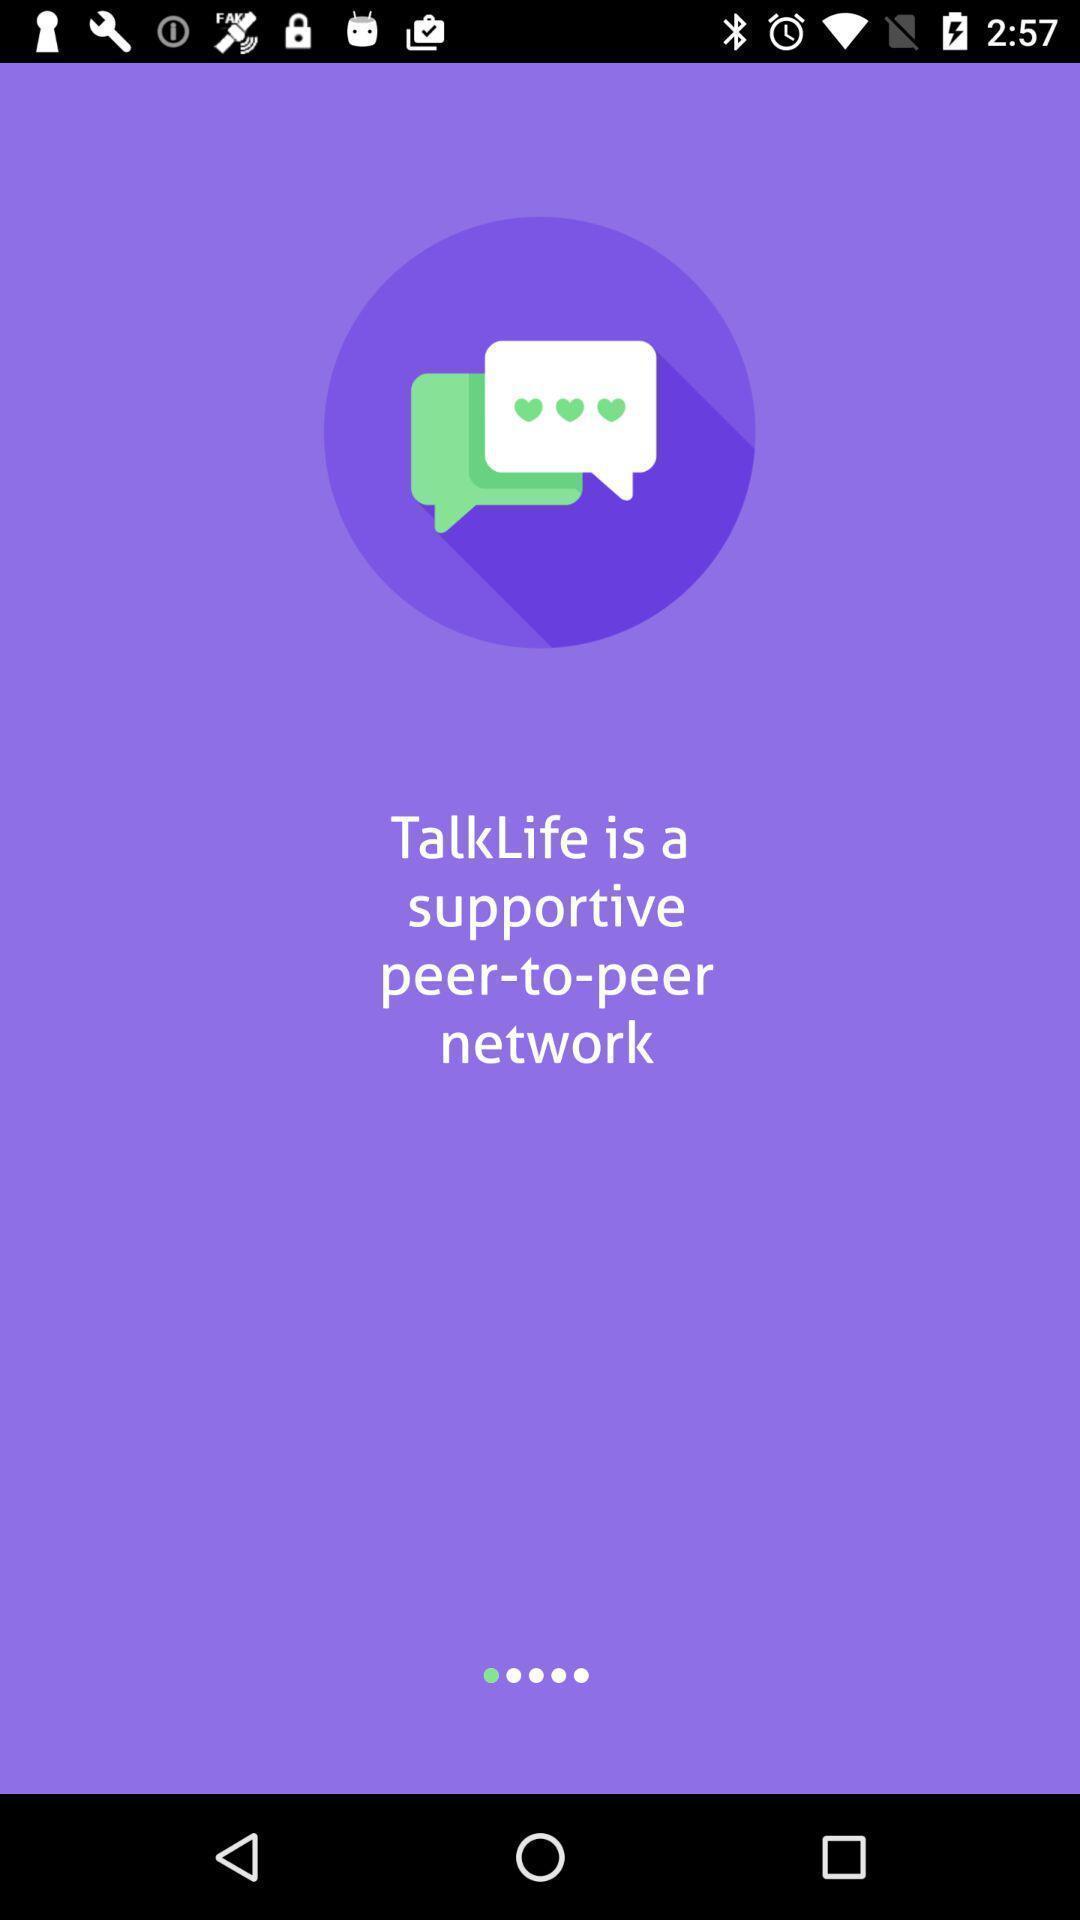What details can you identify in this image? Starting page. 